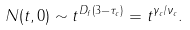Convert formula to latex. <formula><loc_0><loc_0><loc_500><loc_500>N ( t , 0 ) \sim t ^ { D _ { f } ( 3 - \tau _ { c } ) } = t ^ { \gamma _ { c } / \nu _ { c } } .</formula> 